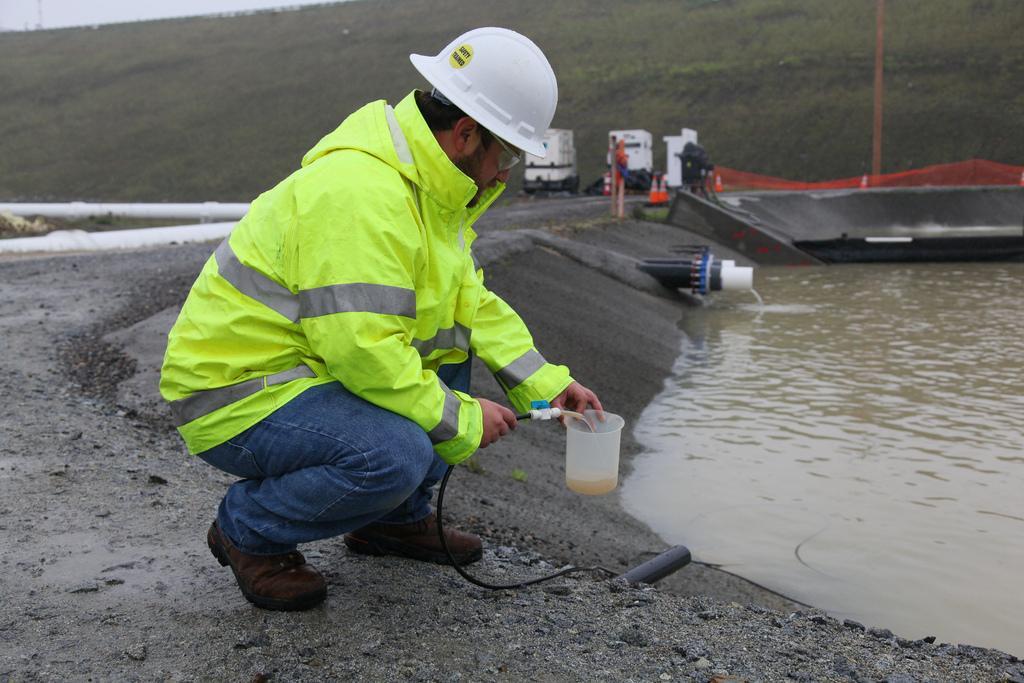Can you describe this image briefly? There is a man sitting like squat position and wore helmet and holding a pipe and mug. We can see water and pipes. In the background we can see vehicles,in,traffic cones,grass and sky. 